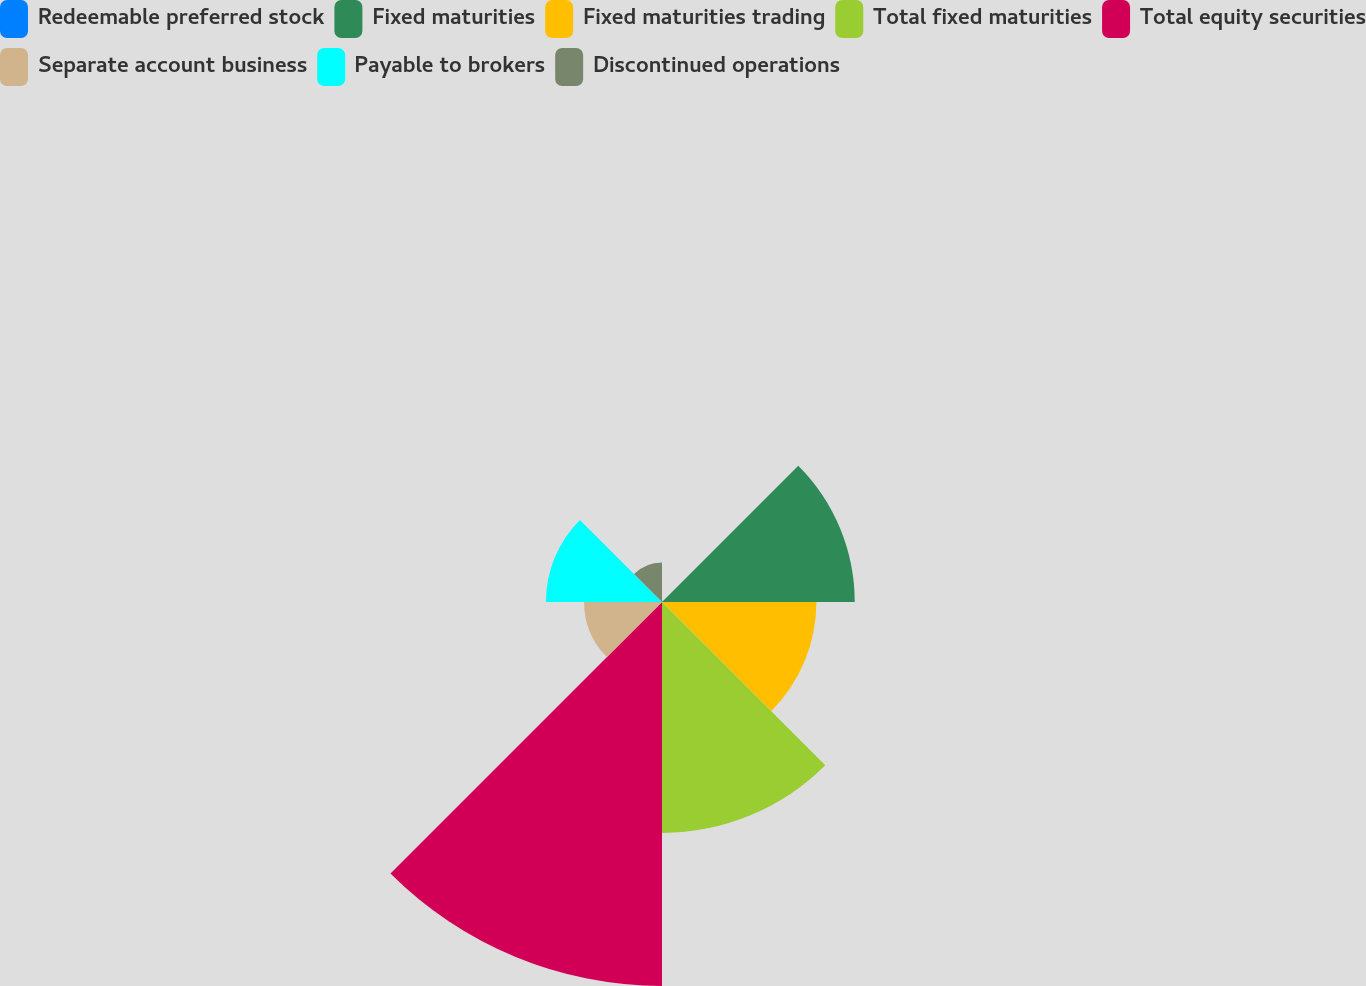<chart> <loc_0><loc_0><loc_500><loc_500><pie_chart><fcel>Redeemable preferred stock<fcel>Fixed maturities<fcel>Fixed maturities trading<fcel>Total fixed maturities<fcel>Total equity securities<fcel>Separate account business<fcel>Payable to brokers<fcel>Discontinued operations<nl><fcel>0.11%<fcel>16.1%<fcel>12.9%<fcel>19.29%<fcel>32.08%<fcel>6.51%<fcel>9.7%<fcel>3.31%<nl></chart> 